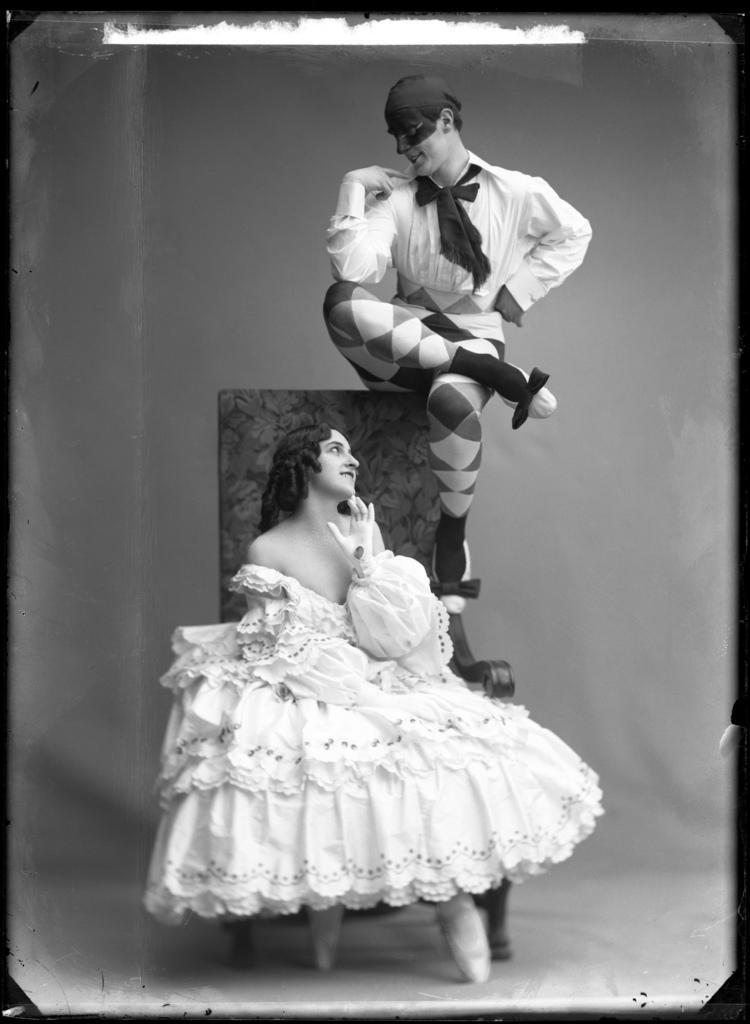Please provide a concise description of this image. This picture consist of an art and in the image I can see a woman sitting on the chair wearing a white color gown and a person sit above the chair 